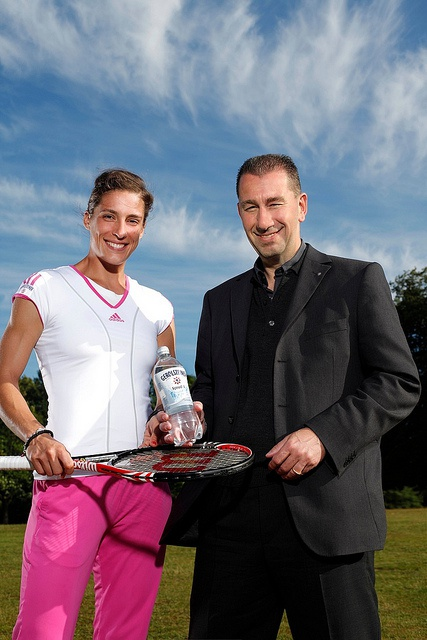Describe the objects in this image and their specific colors. I can see people in darkgray, black, gray, brown, and tan tones, people in darkgray, white, brown, and purple tones, tennis racket in darkgray, black, gray, maroon, and lightgray tones, and bottle in darkgray, lightgray, and gray tones in this image. 